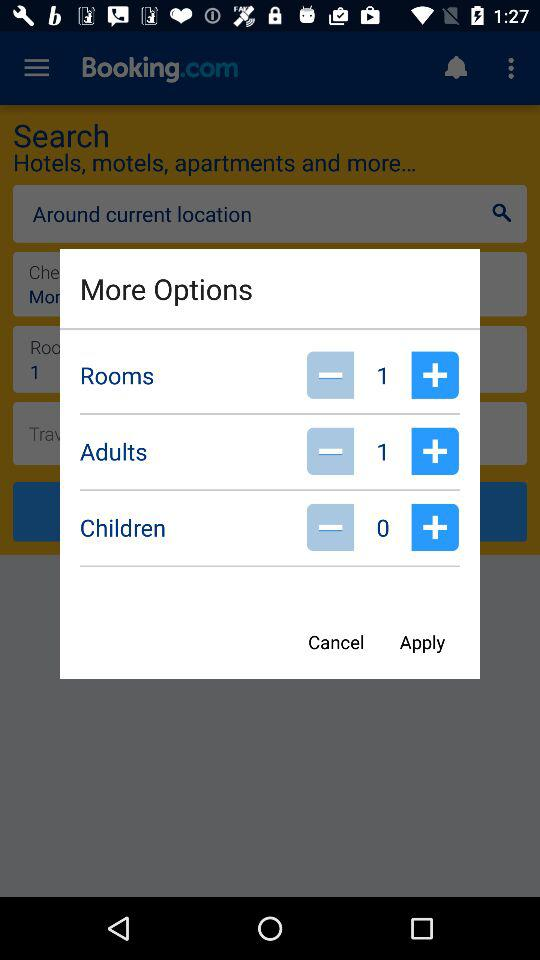How many rooms are added in this option? There is 1 room. 